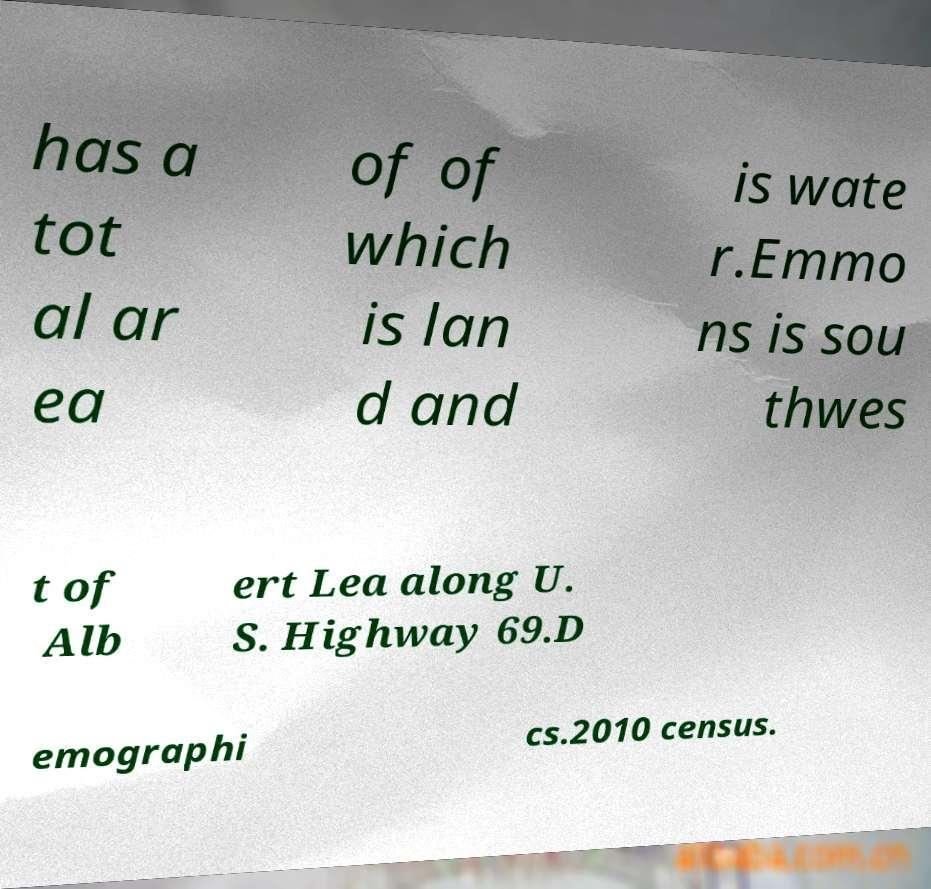Can you read and provide the text displayed in the image?This photo seems to have some interesting text. Can you extract and type it out for me? has a tot al ar ea of of which is lan d and is wate r.Emmo ns is sou thwes t of Alb ert Lea along U. S. Highway 69.D emographi cs.2010 census. 